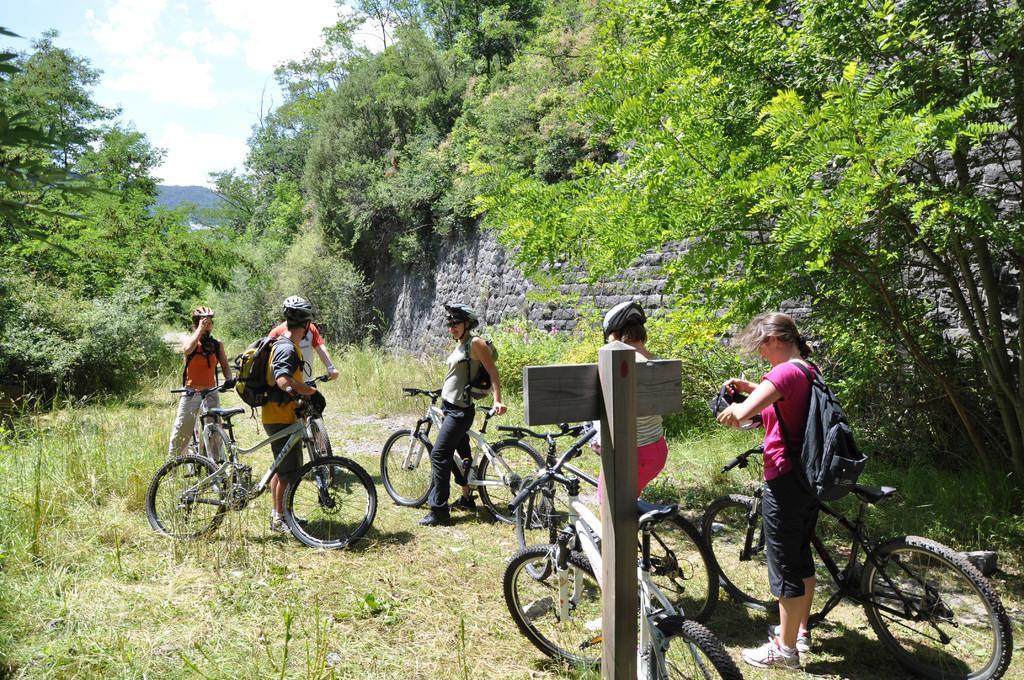How would you summarize this image in a sentence or two? In the center of the image there are group of persons on the cycles. In the background there are trees, plants, wall, hill, sky and clouds. 